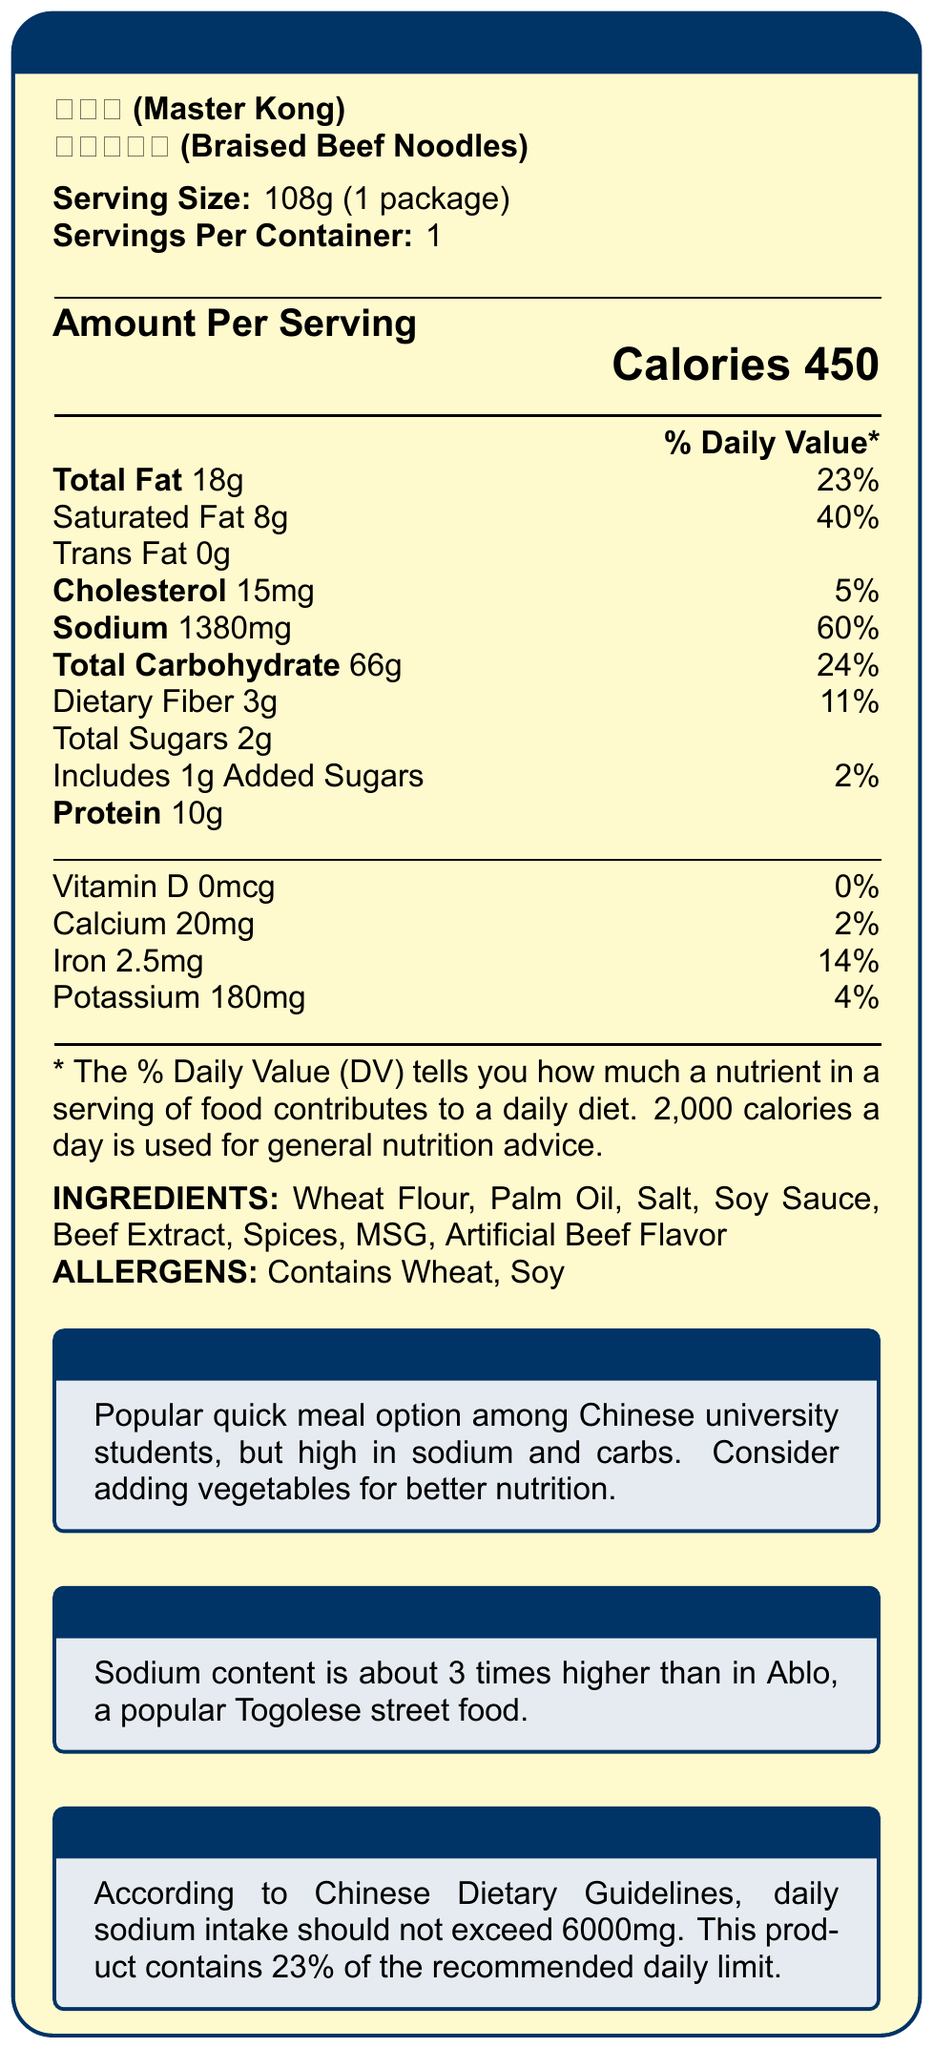what is the serving size of the Braised Beef Noodles? The document states the serving size as 108g, which refers to one package.
Answer: 108g (1 package) how many calories are there per serving? The Nutrition Facts section clearly lists the calories per serving as 450.
Answer: 450 what is the sodium content per serving? The sodium content is listed as 1380mg per serving in the Nutrition Facts section.
Answer: 1380mg what are the primary allergens listed? Under the Allergens section, the products listed are wheat and soy.
Answer: Wheat, Soy how much total carbohydrate is in one serving? The total carbohydrate content per serving is listed as 66g in the Nutrition Facts section.
Answer: 66g how much of the daily recommended sodium limit does one serving represent? According to the Chinese Nutrition Tip, the daily sodium intake should not exceed 6000mg, and this product’s sodium content represents 23% of that limit.
Answer: 23% What are the preparation instructions for the Braised Beef Noodles? The preparation instructions are provided as steps in the document.
Answer: 1. Pour boiling water into the cup. 2. Close lid and wait for 3 minutes. 3. Stir well and enjoy. which nutrient has the highest daily value percentage in one serving? A. Total Fat B. Saturated Fat C. Sodium D. Protein Saturated fat comprises 40% of the daily value, the highest among listed nutrients.
Answer: B how does the sodium content in Braised Beef Noodles compare to Ablo, a popular Togolese street food? The Togolese Comparison section mentions that the sodium content is about 3 times higher than in Ablo.
Answer: About 3 times higher what is the country's origin of this product? Under Manufacturer Info, it states the country of origin as China.
Answer: China which ingredients are listed under the ingredients section? A. Salt, Soy Sauce, Beef Extract, Spices B. Wheat Flour, Corn Oil, MSG, Salt C. Palm Oil, Beef Extract, Spices, Sugar D. Flour, Soybeans, Salt, MSG The listed ingredients are Wheat Flour, Palm Oil, Salt, Soy Sauce, Beef Extract, Spices, MSG, Artificial Beef Flavor.
Answer: A is the product suitable for someone with a soy allergy? The Allergens section clearly indicates that the product contains soy.
Answer: No summarize the main nutritional concerns highlighted in the document. The document emphasizes that while the product is popular among students for its convenience, it is high in sodium (1380mg per serving, 23% of daily recommended intake) and carbohydrates (66g), making it necessary to consider healthier additions like vegetables.
Answer: The product is high in sodium and carbohydrates and contains significant saturated fat, making it a less healthy meal option. Adding vegetables is recommended for better nutrition. what kind of meal option is this product popular for? The Student Tip box indicates that the product is a popular quick meal option among Chinese university students.
Answer: Quick meal option what is the exact storage suggestion provided? Storage instructions provided in the document specifically mention to store in a cool, dry place.
Answer: Store in a cool, dry place how much protein does one serving of Braised Beef Noodles contain? Under the Nutrition Facts, it lists the protein content per serving as 10g.
Answer: 10g how does the document explain the daily value percentage? The explanation is given at the bottom of the Nutrition Facts section in the document.
Answer: The % Daily Value (DV) tells you how much a nutrient in a serving of food contributes to a daily diet. 2,000 calories a day is used for general nutrition advice. what is the manufacturer's address? The manufacturer address given is in Tianjin Economic-Technological Development Area, No. 15, 3rd Avenue.
Answer: No.15, 3rd Avenue, Tianjin Economic-Technological Development Area is this product imported specifically for international students? The import information section states the product is imported by Carrefour China for international students.
Answer: Yes how many servings per container are listed? The Serving Size section lists “1” as the number of servings per container.
Answer: 1 how many grams of added sugars are in one serving of this product? The Nutrition Facts lists added sugars as 1g per serving.
Answer: 1g how many steps are outlined in the preparation instructions? The Preparation Instructions section lists three steps.
Answer: 3 how much calcium is in one serving? The Nutrition Facts lists calcium content as 20mg per serving.
Answer: 20mg which nutrient has the lowest daily value percentage in this product? A. Calcium B. Iron C. Potassium D. Vitamin D Vitamin D has 0% Daily Value, the lowest among listed nutrients.
Answer: D describe the main purpose of the Chinese Nutrition Tip provided in the document. This tip is included to make consumers aware of their sodium intake relative to national dietary guidelines.
Answer: The Chinese Nutrition Tip is meant to inform consumers that the daily sodium intake should not exceed 6000mg and that one serving of this product contains 23% of the recommended daily limit. 